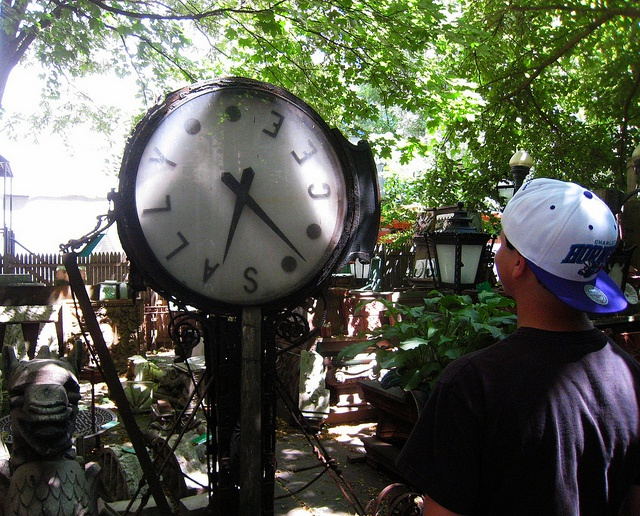Describe the objects in this image and their specific colors. I can see people in white, black, gray, and darkgray tones, clock in white, gray, black, lavender, and darkgray tones, and potted plant in white, black, and darkgreen tones in this image. 